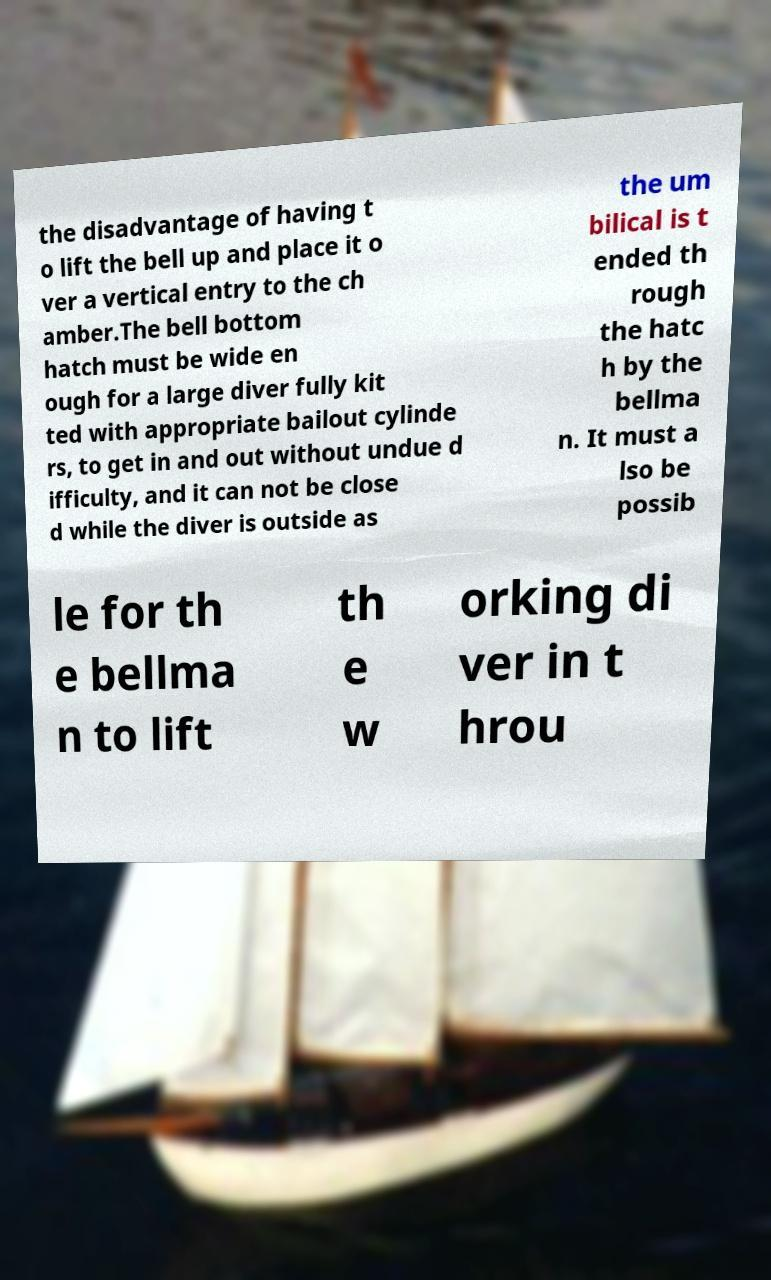Can you read and provide the text displayed in the image?This photo seems to have some interesting text. Can you extract and type it out for me? the disadvantage of having t o lift the bell up and place it o ver a vertical entry to the ch amber.The bell bottom hatch must be wide en ough for a large diver fully kit ted with appropriate bailout cylinde rs, to get in and out without undue d ifficulty, and it can not be close d while the diver is outside as the um bilical is t ended th rough the hatc h by the bellma n. It must a lso be possib le for th e bellma n to lift th e w orking di ver in t hrou 